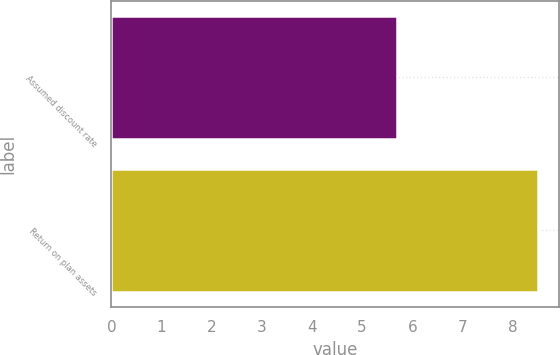Convert chart to OTSL. <chart><loc_0><loc_0><loc_500><loc_500><bar_chart><fcel>Assumed discount rate<fcel>Return on plan assets<nl><fcel>5.7<fcel>8.5<nl></chart> 